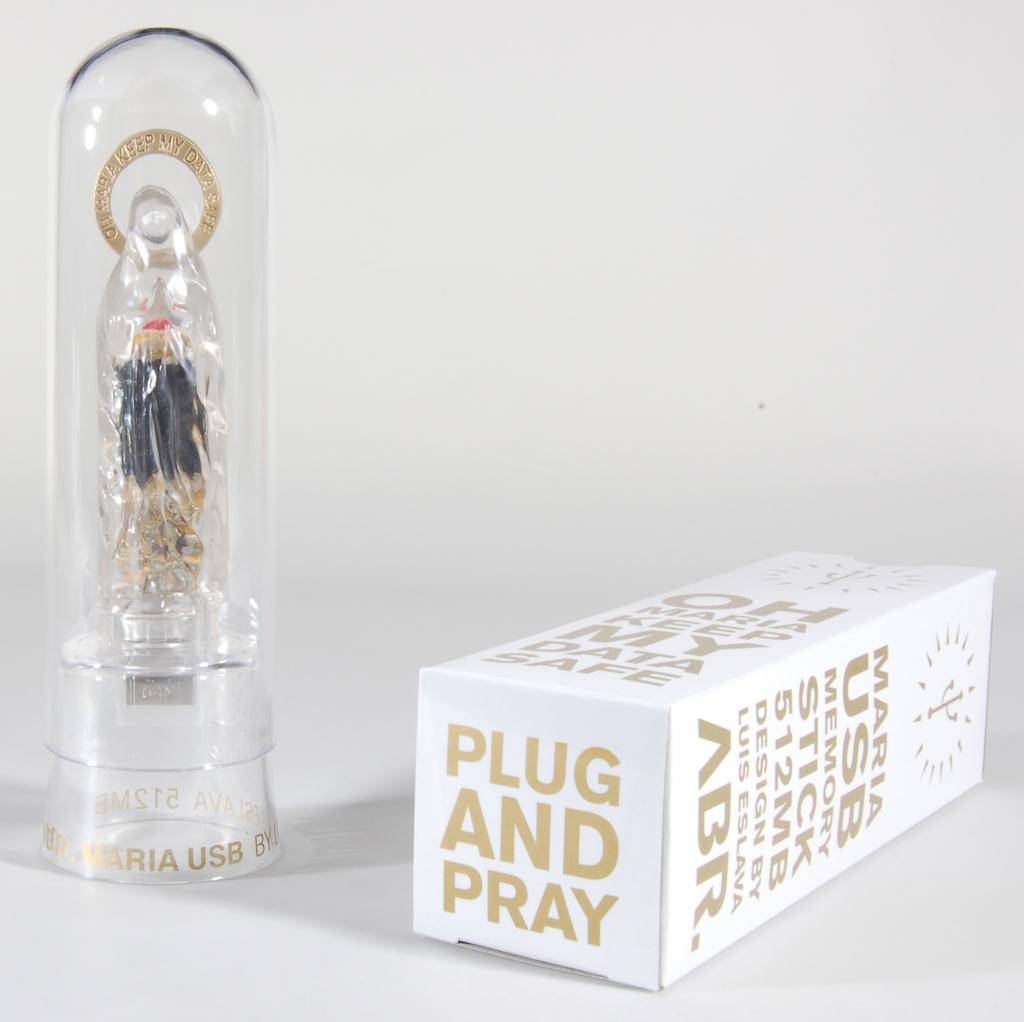<image>
Summarize the visual content of the image. White box of Maria USBmemory stick 512MB plug and pray. 